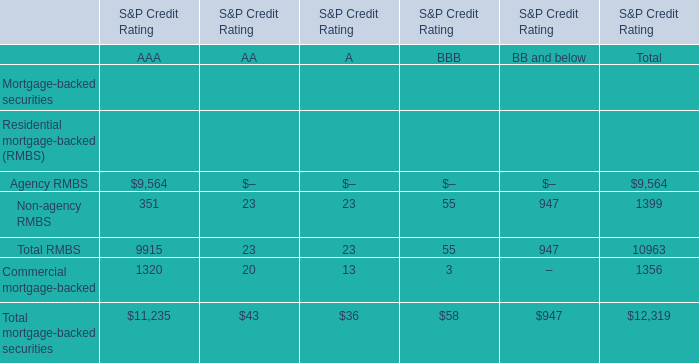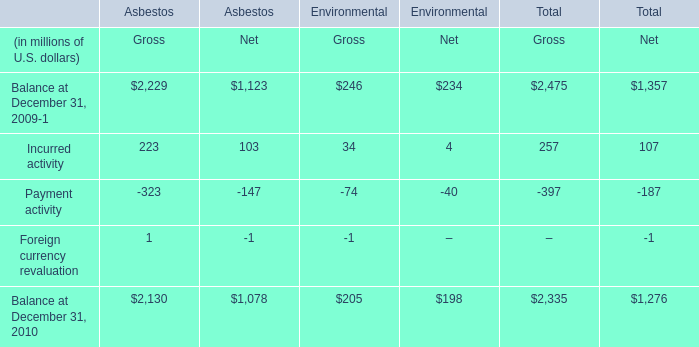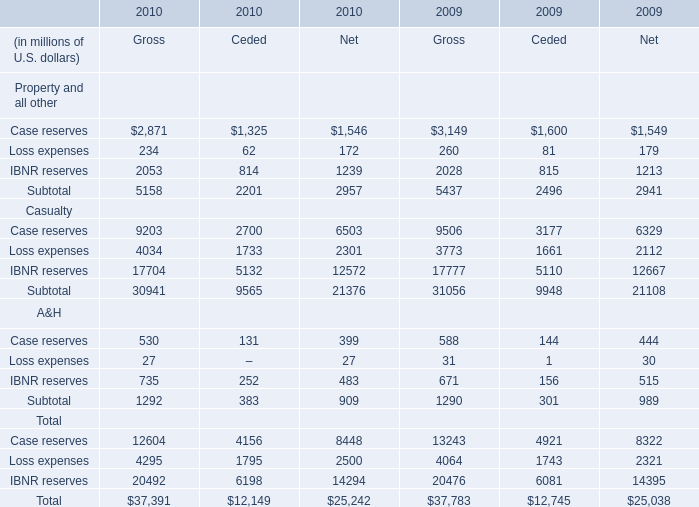What's the sum of IBNR reserves Casualty of 2010 Gross, and Balance at December 31, 2009 of Asbestos Net ? 
Computations: (17704.0 + 1123.0)
Answer: 18827.0. 